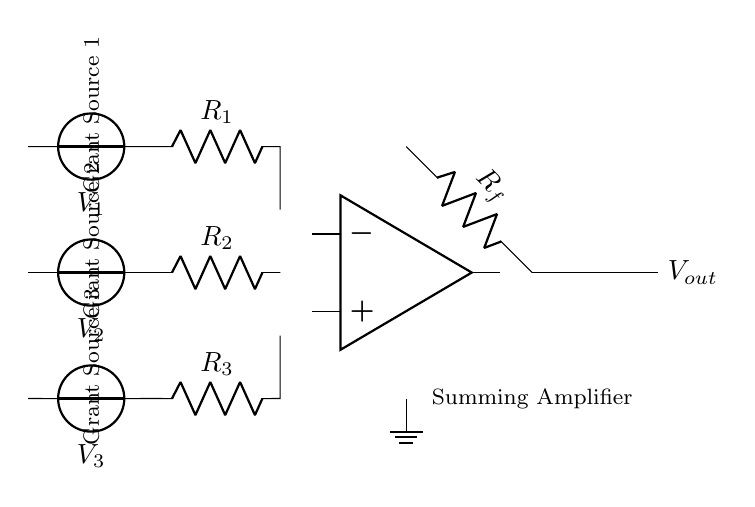What is the total number of input voltage sources in this circuit? The circuit diagram shows three distinct voltage sources labeled as V1, V2, and V3. Each source is connected to an individual resistor leading into the summing amplifier. Counting these sources gives a total of three.
Answer: 3 What is the function of the feedback resistor in the summing amplifier? The feedback resistor, labeled as Rf, is crucial in setting the gain of the summing amplifier. It connects from the output back to the inverting input terminal, helping to determine the overall output voltage based on the input voltages and the resistors' values.
Answer: To set the gain What are the labels for the grant sources? The circuit diagram indicates three grant sources through labels that are associated with each voltage source: Grant Source 1 for V1, Grant Source 2 for V2, and Grant Source 3 for V3.
Answer: Grant Source 1, Grant Source 2, Grant Source 3 What is the output connection labeled as? The output of the circuit, where the summed voltage appears, is labeled as Vout. This signifies the voltage resulting from the combination of the inputs through the amplifier.
Answer: Vout What is the purpose of the ground symbol in this circuit? The ground symbol is critical as it establishes a common reference point for the voltage levels across the circuit. It helps in ensuring the proper functioning of voltage references and defines zero voltage in the context of the circuit.
Answer: Reference point What happens to the output voltage if we increase Rf? Increasing the feedback resistor Rf will generally increase the voltage gain of the summing amplifier, resulting in a higher output voltage for the same applied input voltages. The relationship is defined by the formula for the summing amplifier gain, which indicates the direct influence of Rf on the output.
Answer: Increases output voltage What is the expected effect on the output if all input voltages are zero? If all input voltages (V1, V2, and V3) are at zero, the output voltage Vout will also be zero since the values added by the summing amplifier will yield a total of zero. This is because the output directly depends on the inputs.
Answer: Vout equals zero 